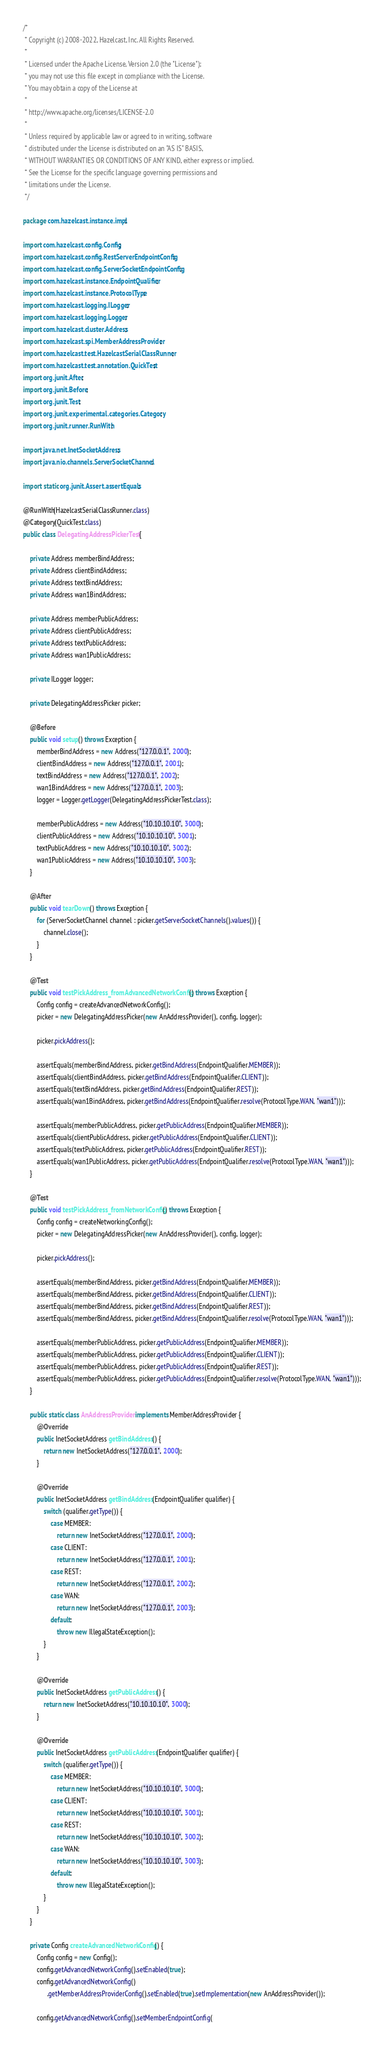Convert code to text. <code><loc_0><loc_0><loc_500><loc_500><_Java_>/*
 * Copyright (c) 2008-2022, Hazelcast, Inc. All Rights Reserved.
 *
 * Licensed under the Apache License, Version 2.0 (the "License");
 * you may not use this file except in compliance with the License.
 * You may obtain a copy of the License at
 *
 * http://www.apache.org/licenses/LICENSE-2.0
 *
 * Unless required by applicable law or agreed to in writing, software
 * distributed under the License is distributed on an "AS IS" BASIS,
 * WITHOUT WARRANTIES OR CONDITIONS OF ANY KIND, either express or implied.
 * See the License for the specific language governing permissions and
 * limitations under the License.
 */

package com.hazelcast.instance.impl;

import com.hazelcast.config.Config;
import com.hazelcast.config.RestServerEndpointConfig;
import com.hazelcast.config.ServerSocketEndpointConfig;
import com.hazelcast.instance.EndpointQualifier;
import com.hazelcast.instance.ProtocolType;
import com.hazelcast.logging.ILogger;
import com.hazelcast.logging.Logger;
import com.hazelcast.cluster.Address;
import com.hazelcast.spi.MemberAddressProvider;
import com.hazelcast.test.HazelcastSerialClassRunner;
import com.hazelcast.test.annotation.QuickTest;
import org.junit.After;
import org.junit.Before;
import org.junit.Test;
import org.junit.experimental.categories.Category;
import org.junit.runner.RunWith;

import java.net.InetSocketAddress;
import java.nio.channels.ServerSocketChannel;

import static org.junit.Assert.assertEquals;

@RunWith(HazelcastSerialClassRunner.class)
@Category(QuickTest.class)
public class DelegatingAddressPickerTest {

    private Address memberBindAddress;
    private Address clientBindAddress;
    private Address textBindAddress;
    private Address wan1BindAddress;

    private Address memberPublicAddress;
    private Address clientPublicAddress;
    private Address textPublicAddress;
    private Address wan1PublicAddress;

    private ILogger logger;

    private DelegatingAddressPicker picker;

    @Before
    public void setup() throws Exception {
        memberBindAddress = new Address("127.0.0.1", 2000);
        clientBindAddress = new Address("127.0.0.1", 2001);
        textBindAddress = new Address("127.0.0.1", 2002);
        wan1BindAddress = new Address("127.0.0.1", 2003);
        logger = Logger.getLogger(DelegatingAddressPickerTest.class);

        memberPublicAddress = new Address("10.10.10.10", 3000);
        clientPublicAddress = new Address("10.10.10.10", 3001);
        textPublicAddress = new Address("10.10.10.10", 3002);
        wan1PublicAddress = new Address("10.10.10.10", 3003);
    }

    @After
    public void tearDown() throws Exception {
        for (ServerSocketChannel channel : picker.getServerSocketChannels().values()) {
            channel.close();
        }
    }

    @Test
    public void testPickAddress_fromAdvancedNetworkConfig() throws Exception {
        Config config = createAdvancedNetworkConfig();
        picker = new DelegatingAddressPicker(new AnAddressProvider(), config, logger);

        picker.pickAddress();

        assertEquals(memberBindAddress, picker.getBindAddress(EndpointQualifier.MEMBER));
        assertEquals(clientBindAddress, picker.getBindAddress(EndpointQualifier.CLIENT));
        assertEquals(textBindAddress, picker.getBindAddress(EndpointQualifier.REST));
        assertEquals(wan1BindAddress, picker.getBindAddress(EndpointQualifier.resolve(ProtocolType.WAN, "wan1")));

        assertEquals(memberPublicAddress, picker.getPublicAddress(EndpointQualifier.MEMBER));
        assertEquals(clientPublicAddress, picker.getPublicAddress(EndpointQualifier.CLIENT));
        assertEquals(textPublicAddress, picker.getPublicAddress(EndpointQualifier.REST));
        assertEquals(wan1PublicAddress, picker.getPublicAddress(EndpointQualifier.resolve(ProtocolType.WAN, "wan1")));
    }

    @Test
    public void testPickAddress_fromNetworkConfig() throws Exception {
        Config config = createNetworkingConfig();
        picker = new DelegatingAddressPicker(new AnAddressProvider(), config, logger);

        picker.pickAddress();

        assertEquals(memberBindAddress, picker.getBindAddress(EndpointQualifier.MEMBER));
        assertEquals(memberBindAddress, picker.getBindAddress(EndpointQualifier.CLIENT));
        assertEquals(memberBindAddress, picker.getBindAddress(EndpointQualifier.REST));
        assertEquals(memberBindAddress, picker.getBindAddress(EndpointQualifier.resolve(ProtocolType.WAN, "wan1")));

        assertEquals(memberPublicAddress, picker.getPublicAddress(EndpointQualifier.MEMBER));
        assertEquals(memberPublicAddress, picker.getPublicAddress(EndpointQualifier.CLIENT));
        assertEquals(memberPublicAddress, picker.getPublicAddress(EndpointQualifier.REST));
        assertEquals(memberPublicAddress, picker.getPublicAddress(EndpointQualifier.resolve(ProtocolType.WAN, "wan1")));
    }

    public static class AnAddressProvider implements MemberAddressProvider {
        @Override
        public InetSocketAddress getBindAddress() {
            return new InetSocketAddress("127.0.0.1", 2000);
        }

        @Override
        public InetSocketAddress getBindAddress(EndpointQualifier qualifier) {
            switch (qualifier.getType()) {
                case MEMBER:
                    return new InetSocketAddress("127.0.0.1", 2000);
                case CLIENT:
                    return new InetSocketAddress("127.0.0.1", 2001);
                case REST:
                    return new InetSocketAddress("127.0.0.1", 2002);
                case WAN:
                    return new InetSocketAddress("127.0.0.1", 2003);
                default:
                    throw new IllegalStateException();
            }
        }

        @Override
        public InetSocketAddress getPublicAddress() {
            return new InetSocketAddress("10.10.10.10", 3000);
        }

        @Override
        public InetSocketAddress getPublicAddress(EndpointQualifier qualifier) {
            switch (qualifier.getType()) {
                case MEMBER:
                    return new InetSocketAddress("10.10.10.10", 3000);
                case CLIENT:
                    return new InetSocketAddress("10.10.10.10", 3001);
                case REST:
                    return new InetSocketAddress("10.10.10.10", 3002);
                case WAN:
                    return new InetSocketAddress("10.10.10.10", 3003);
                default:
                    throw new IllegalStateException();
            }
        }
    }

    private Config createAdvancedNetworkConfig() {
        Config config = new Config();
        config.getAdvancedNetworkConfig().setEnabled(true);
        config.getAdvancedNetworkConfig()
              .getMemberAddressProviderConfig().setEnabled(true).setImplementation(new AnAddressProvider());

        config.getAdvancedNetworkConfig().setMemberEndpointConfig(</code> 